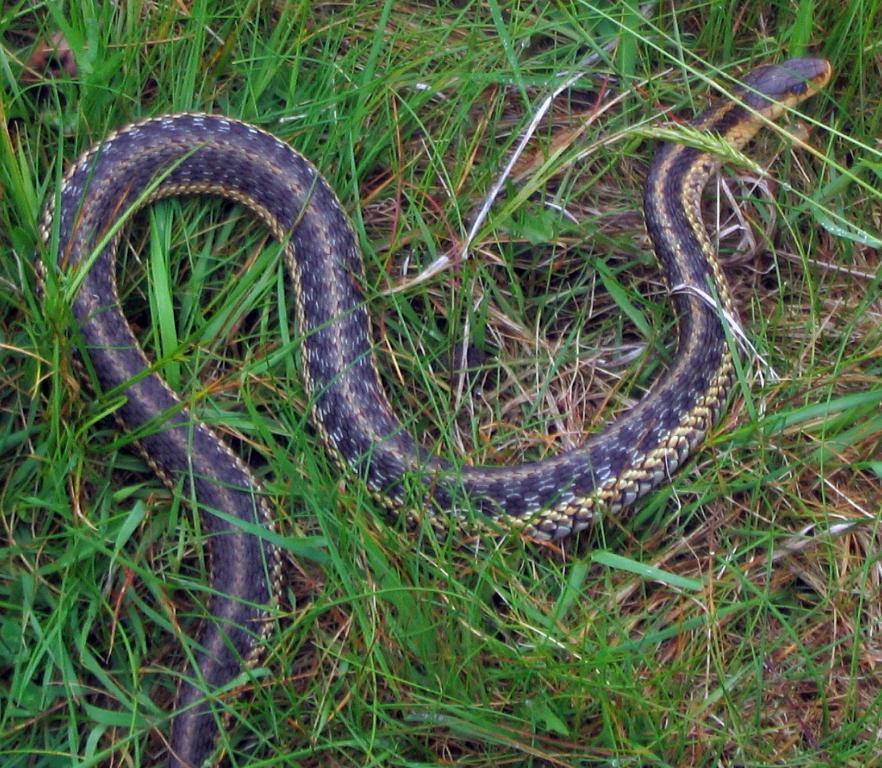What type of animal is in the image? There is a snake in the image. What colors can be seen on the snake? The snake has black and cream color. What type of vegetation is present in the image? There is grass in the image. What color is the grass? The grass is green. What grade does the snake have in the image? There is no indication of a grade or any educational context in the image; it simply features a snake and grass. 